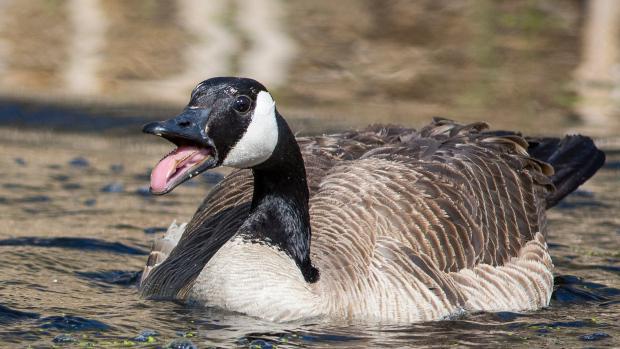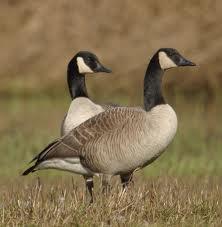The first image is the image on the left, the second image is the image on the right. Analyze the images presented: Is the assertion "All the geese have completely white heads." valid? Answer yes or no. No. 